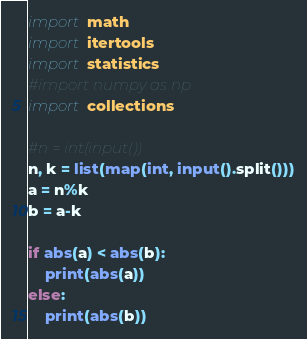Convert code to text. <code><loc_0><loc_0><loc_500><loc_500><_Python_>
import math
import itertools
import statistics
#import numpy as np
import collections

#n = int(input())
n, k = list(map(int, input().split()))
a = n%k
b = a-k

if abs(a) < abs(b):
    print(abs(a))
else:
    print(abs(b))</code> 